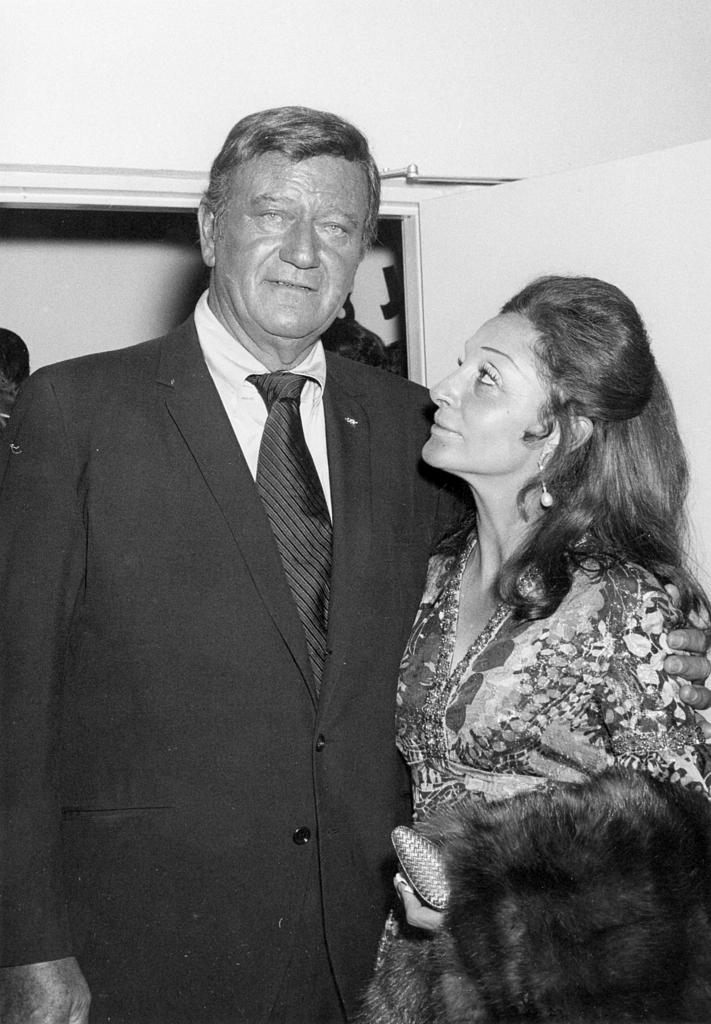What is the person in the image wearing? The person in the image is wearing a suit. What is the person in the suit doing? The person in the suit is standing. Who is standing beside the person in the suit? There is a woman standing beside the person in the suit. What is the woman doing in the image? The woman is looking at the person in the suit. What can be seen in the background of the image? There are other objects in the background of the image. What type of soup is being served in the image? There is no soup present in the image. Can you tell me how many elbows the person in the suit has? The person in the suit has two elbows, but this question is not relevant to the image as it does not focus on any specific detail provided in the facts. 